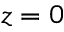<formula> <loc_0><loc_0><loc_500><loc_500>z = 0</formula> 